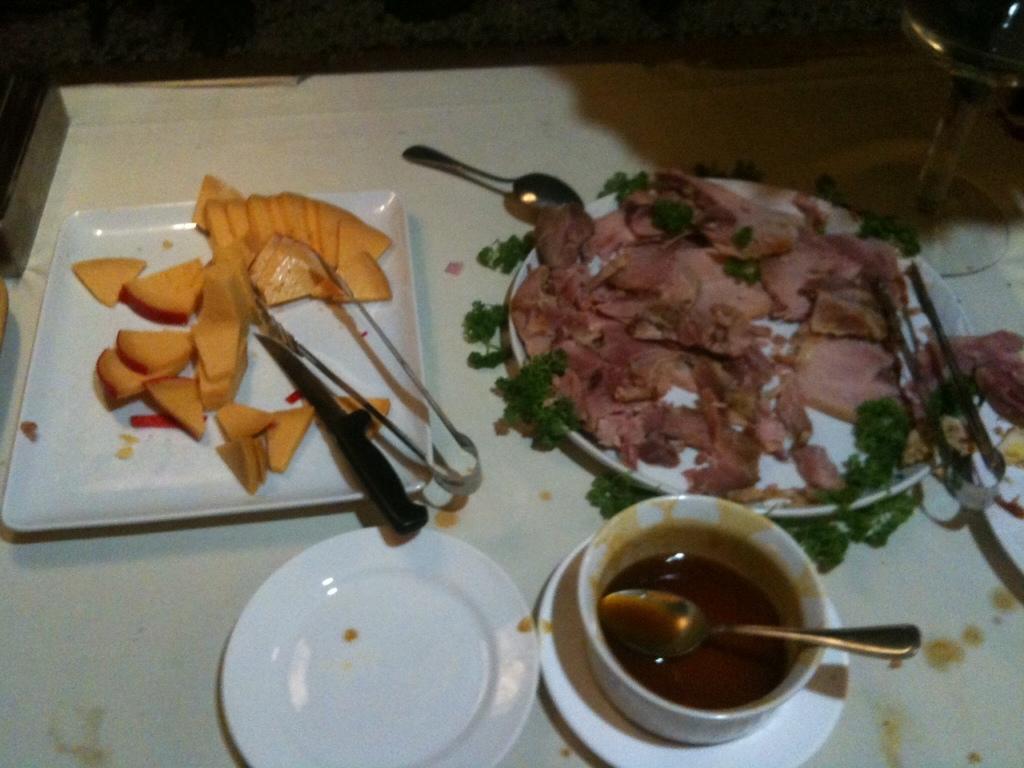In one or two sentences, can you explain what this image depicts? In this image we can see some food on the plates. There are few utensils in the image. There is a drink glass at the right side of the image. 